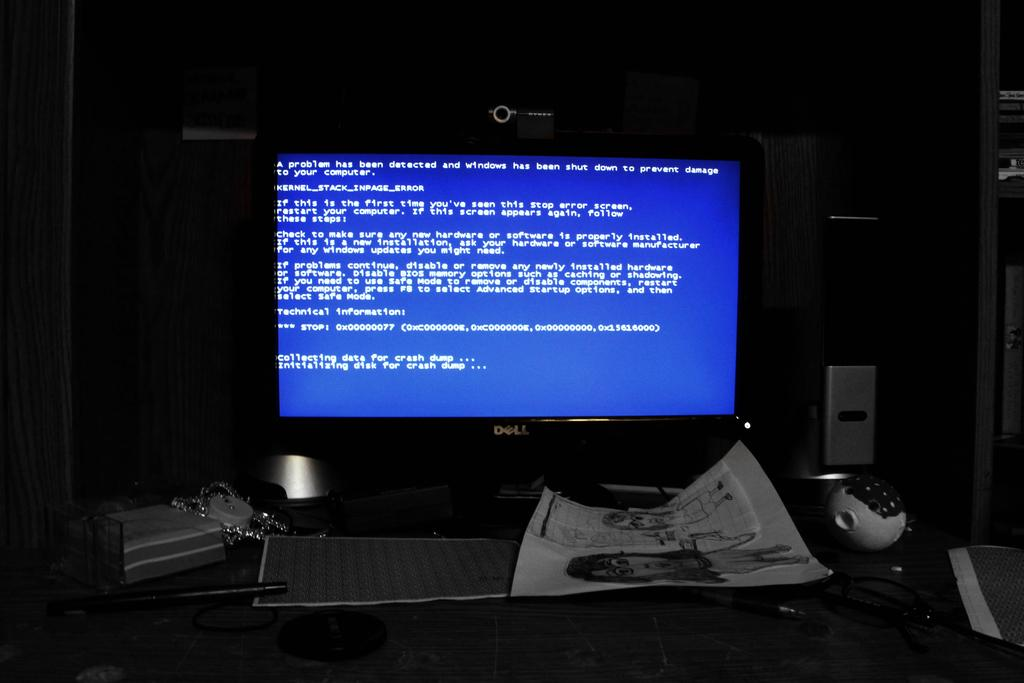What is on the table in the image? There is a monitor, papers, and a pen on the table. What might be used for writing on the papers? The pen on the table might be used for writing on the papers. What is the background of the image made of? The background of the image has a wooden wall. What can be seen on the right side of the image? There are shelves on the right side of the image. What is on the shelves? There are objects on the shelves. Can you see a robin perched on the monitor in the image? No, there is no robin present in the image. 